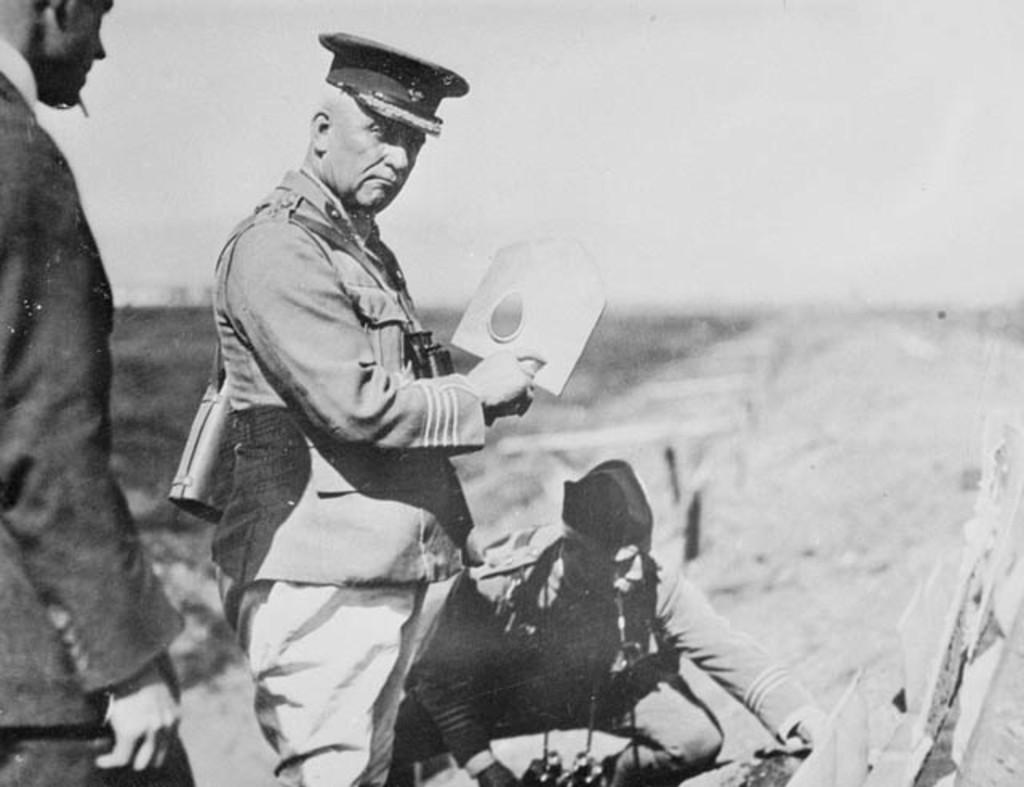What is the color scheme of the image? The image is black and white. Can you describe the subjects in the image? There are people in the image. Are there any specific details about the people's attire? Some people are wearing uniforms. What are some of the people doing in the image? Some people are holding objects in their hands. What can you tell about the background of the image? The background is not clear. What type of basket is being used by the people in the image? There is no basket present in the image. Can you describe the truck that is visible in the image? There is no truck present in the image. 